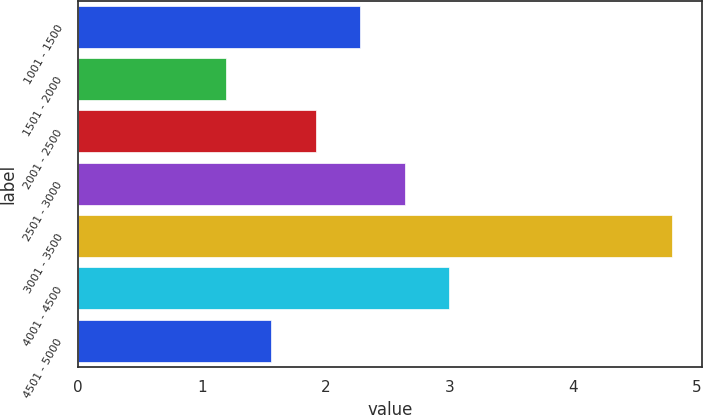Convert chart. <chart><loc_0><loc_0><loc_500><loc_500><bar_chart><fcel>1001 - 1500<fcel>1501 - 2000<fcel>2001 - 2500<fcel>2501 - 3000<fcel>3001 - 3500<fcel>4001 - 4500<fcel>4501 - 5000<nl><fcel>2.28<fcel>1.2<fcel>1.92<fcel>2.64<fcel>4.8<fcel>3<fcel>1.56<nl></chart> 